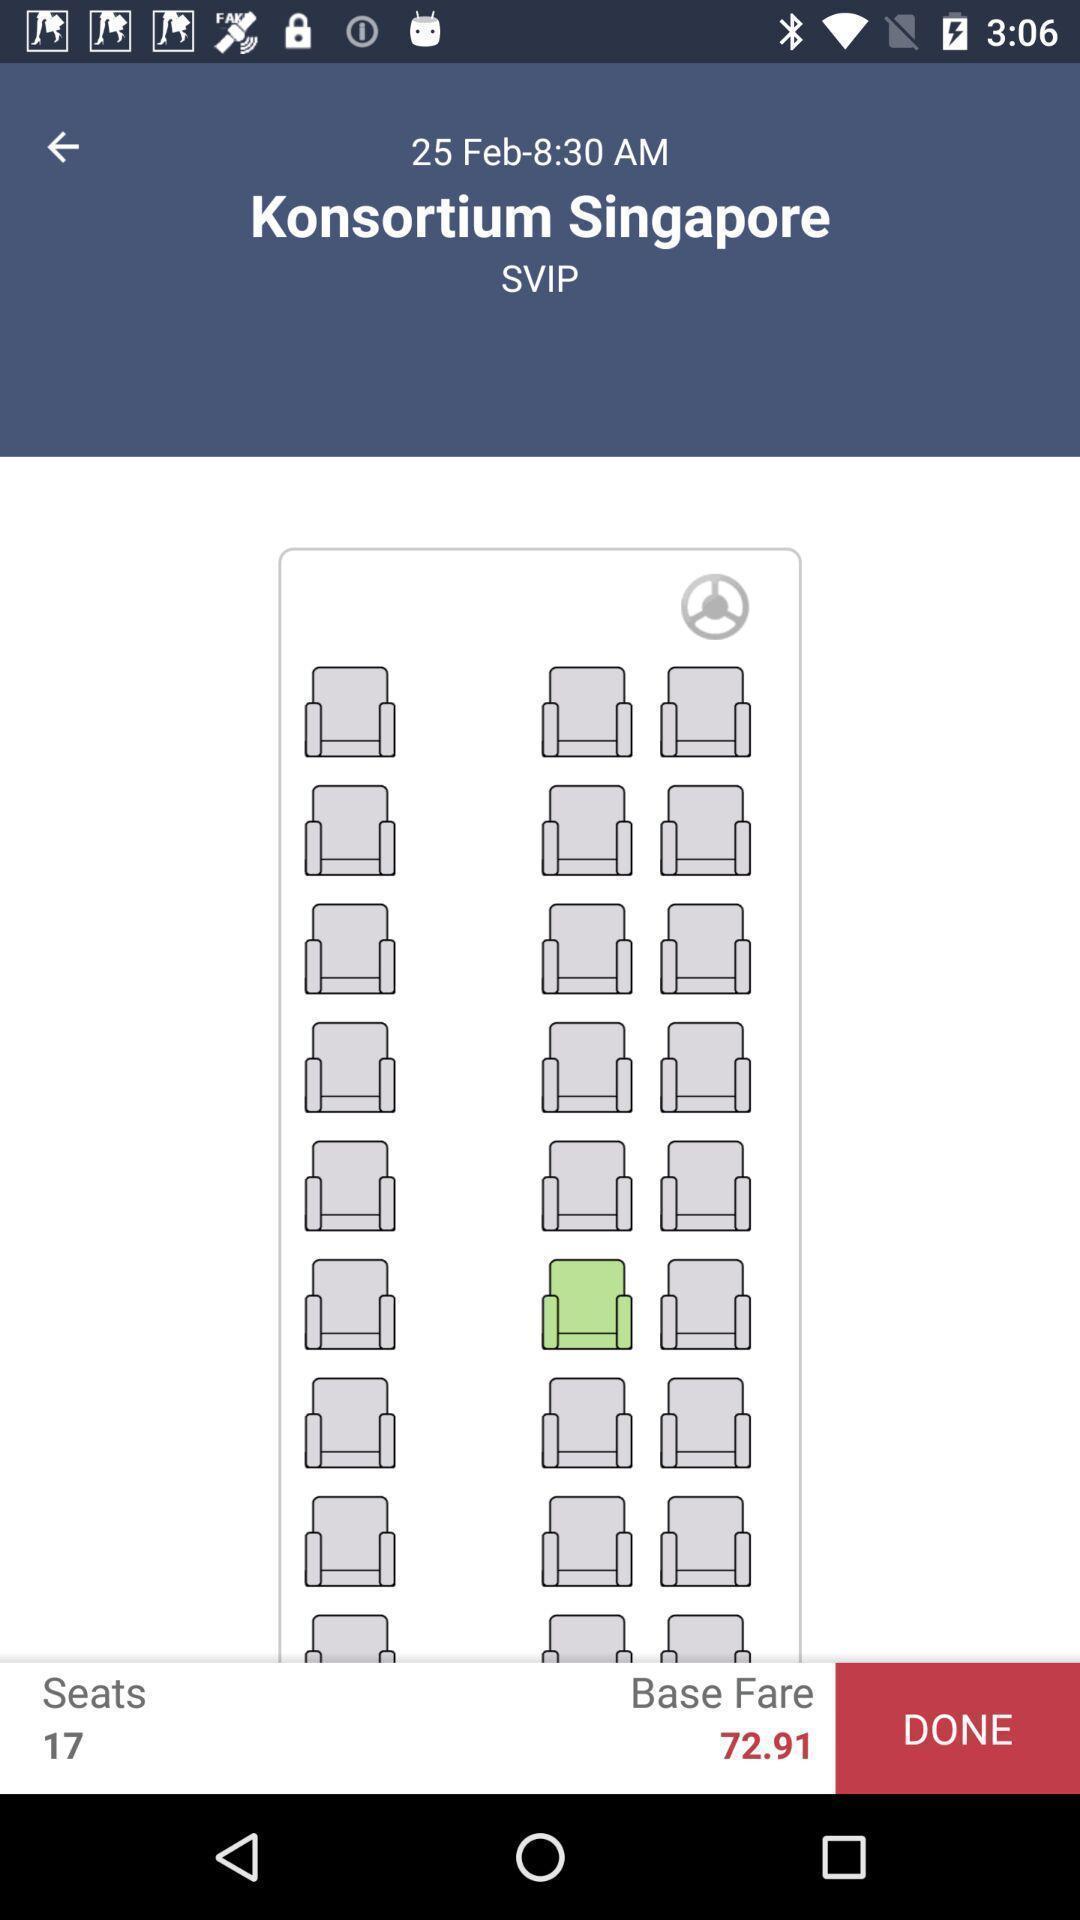Give me a summary of this screen capture. Page displays available seats to book bus tickets. 